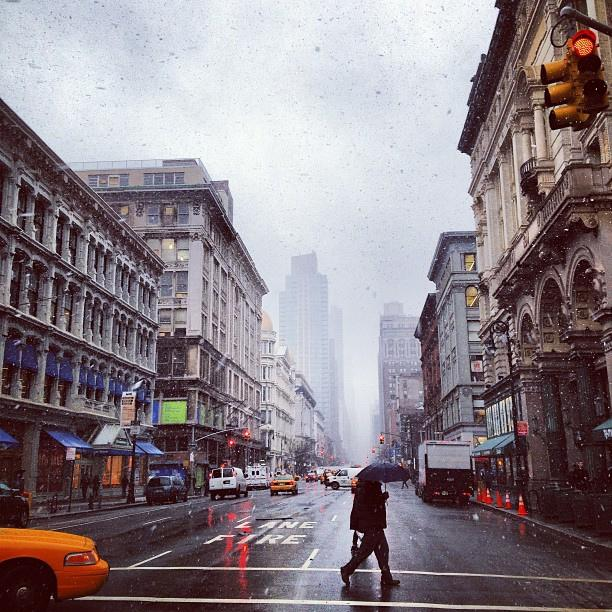What kind of vehicle can park in the middle lane? Please explain your reasoning. fire truck. The truck can park. 